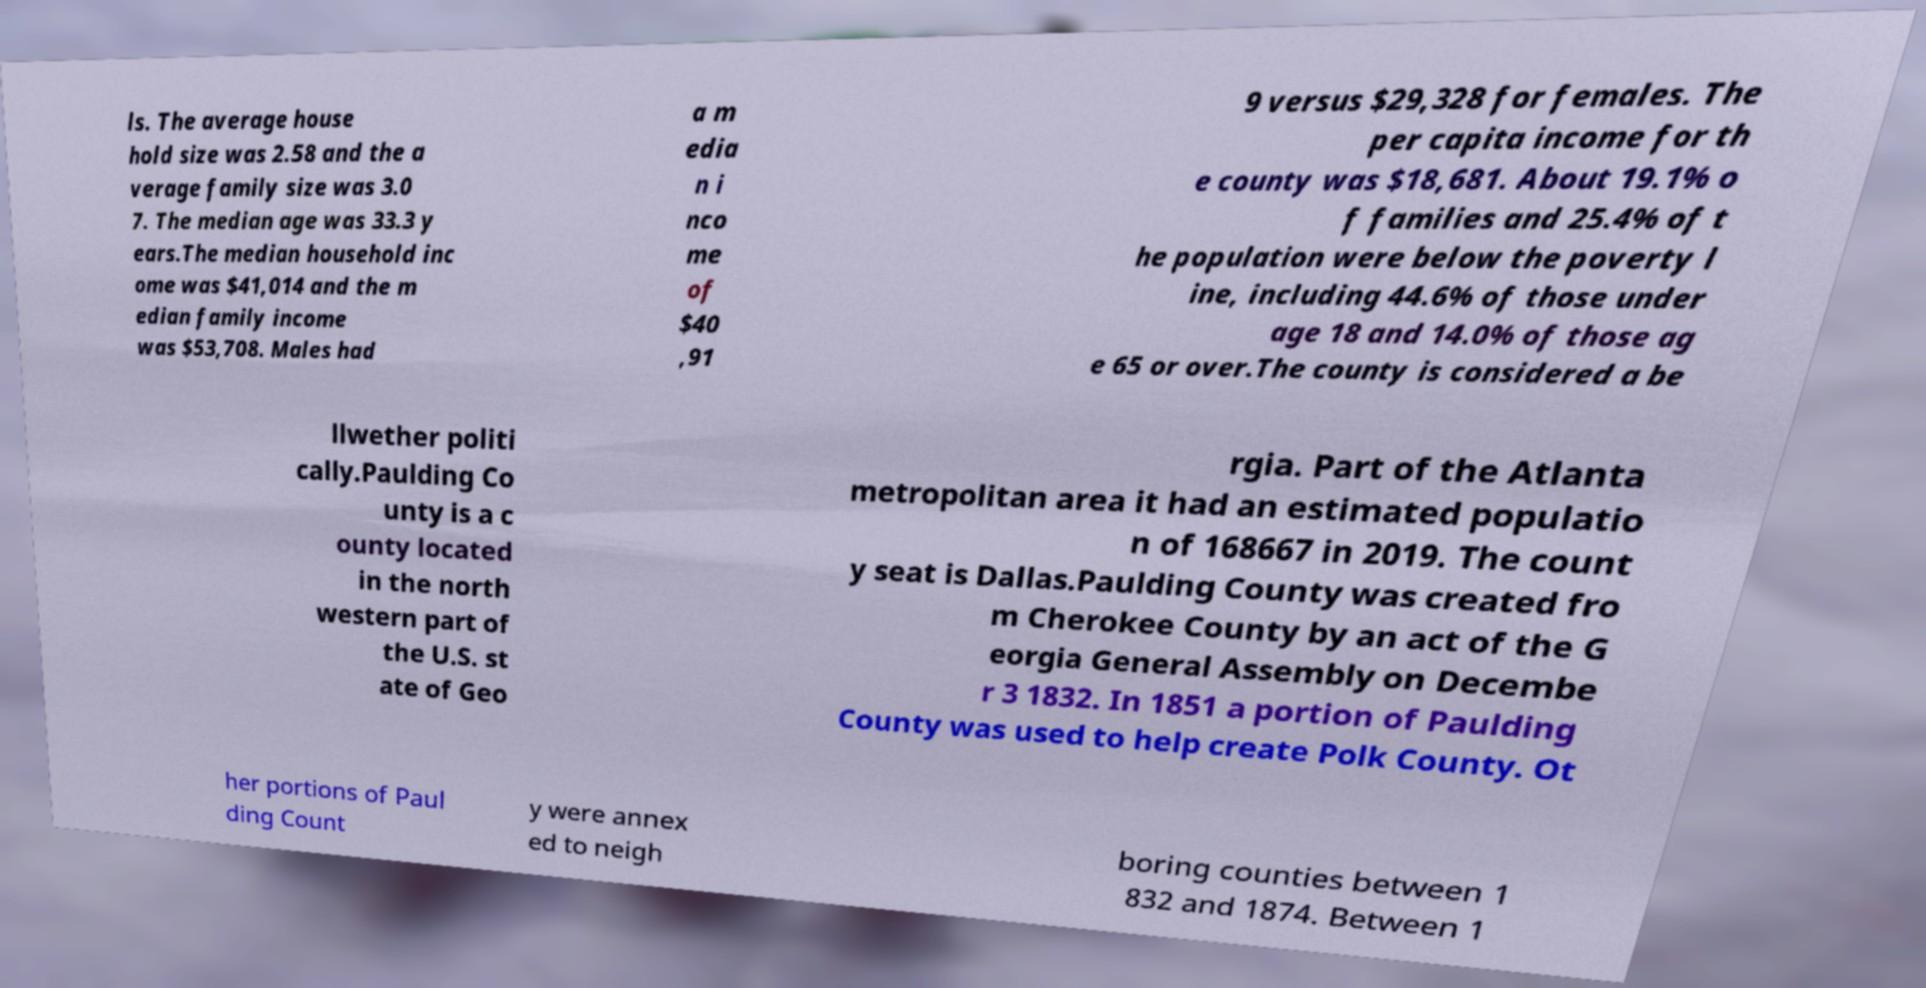For documentation purposes, I need the text within this image transcribed. Could you provide that? ls. The average house hold size was 2.58 and the a verage family size was 3.0 7. The median age was 33.3 y ears.The median household inc ome was $41,014 and the m edian family income was $53,708. Males had a m edia n i nco me of $40 ,91 9 versus $29,328 for females. The per capita income for th e county was $18,681. About 19.1% o f families and 25.4% of t he population were below the poverty l ine, including 44.6% of those under age 18 and 14.0% of those ag e 65 or over.The county is considered a be llwether politi cally.Paulding Co unty is a c ounty located in the north western part of the U.S. st ate of Geo rgia. Part of the Atlanta metropolitan area it had an estimated populatio n of 168667 in 2019. The count y seat is Dallas.Paulding County was created fro m Cherokee County by an act of the G eorgia General Assembly on Decembe r 3 1832. In 1851 a portion of Paulding County was used to help create Polk County. Ot her portions of Paul ding Count y were annex ed to neigh boring counties between 1 832 and 1874. Between 1 